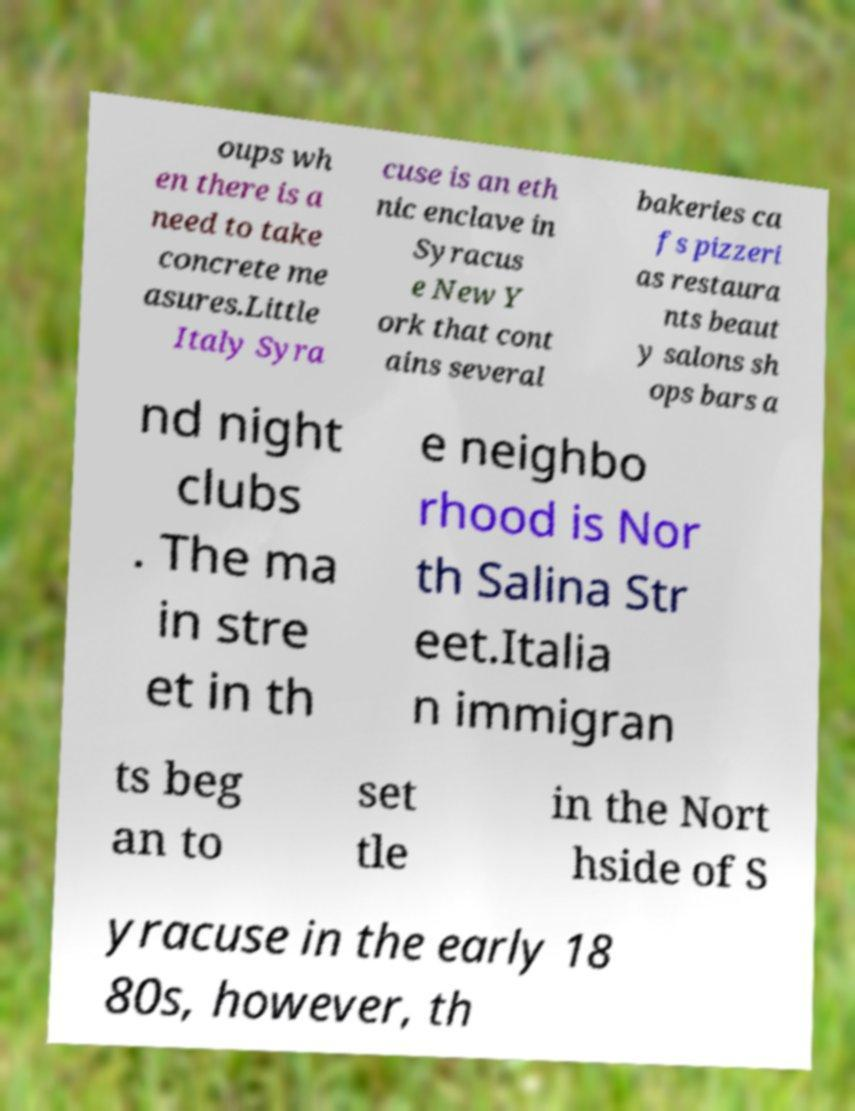There's text embedded in this image that I need extracted. Can you transcribe it verbatim? oups wh en there is a need to take concrete me asures.Little Italy Syra cuse is an eth nic enclave in Syracus e New Y ork that cont ains several bakeries ca fs pizzeri as restaura nts beaut y salons sh ops bars a nd night clubs . The ma in stre et in th e neighbo rhood is Nor th Salina Str eet.Italia n immigran ts beg an to set tle in the Nort hside of S yracuse in the early 18 80s, however, th 